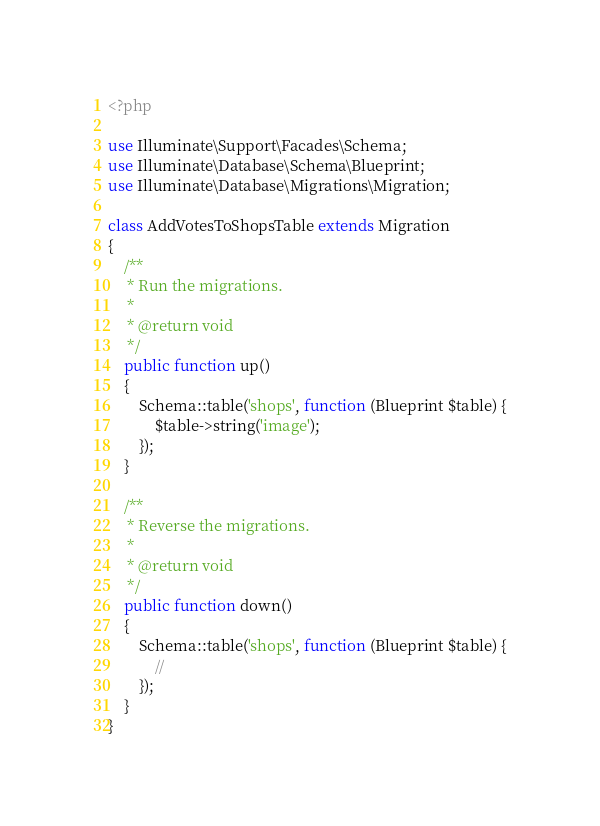<code> <loc_0><loc_0><loc_500><loc_500><_PHP_><?php

use Illuminate\Support\Facades\Schema;
use Illuminate\Database\Schema\Blueprint;
use Illuminate\Database\Migrations\Migration;

class AddVotesToShopsTable extends Migration
{
    /**
     * Run the migrations.
     *
     * @return void
     */
    public function up()
    {
        Schema::table('shops', function (Blueprint $table) {
            $table->string('image');
        });
    }

    /**
     * Reverse the migrations.
     *
     * @return void
     */
    public function down()
    {
        Schema::table('shops', function (Blueprint $table) {
            //
        });
    }
}
</code> 